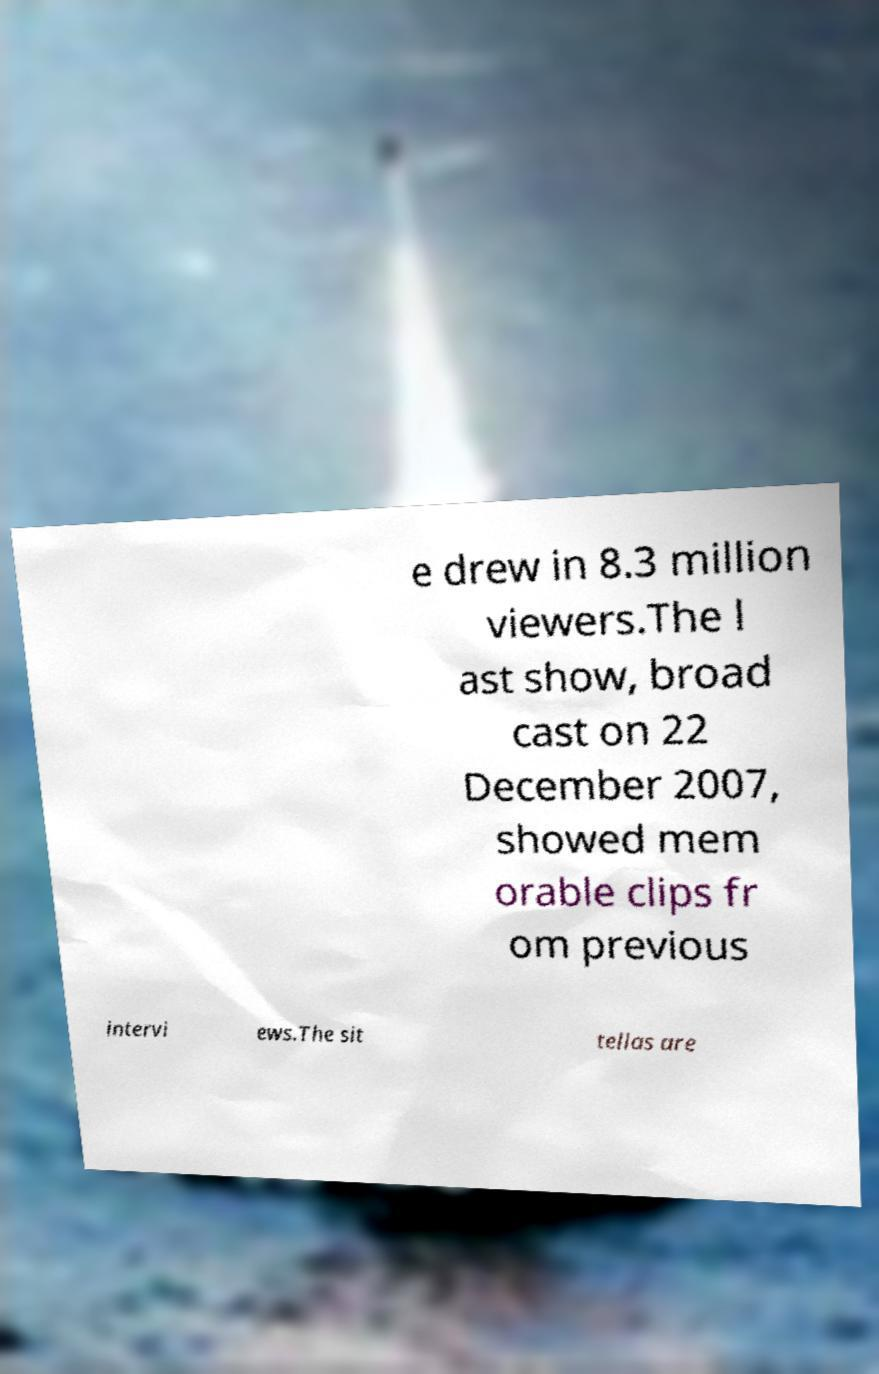Could you extract and type out the text from this image? e drew in 8.3 million viewers.The l ast show, broad cast on 22 December 2007, showed mem orable clips fr om previous intervi ews.The sit tellas are 